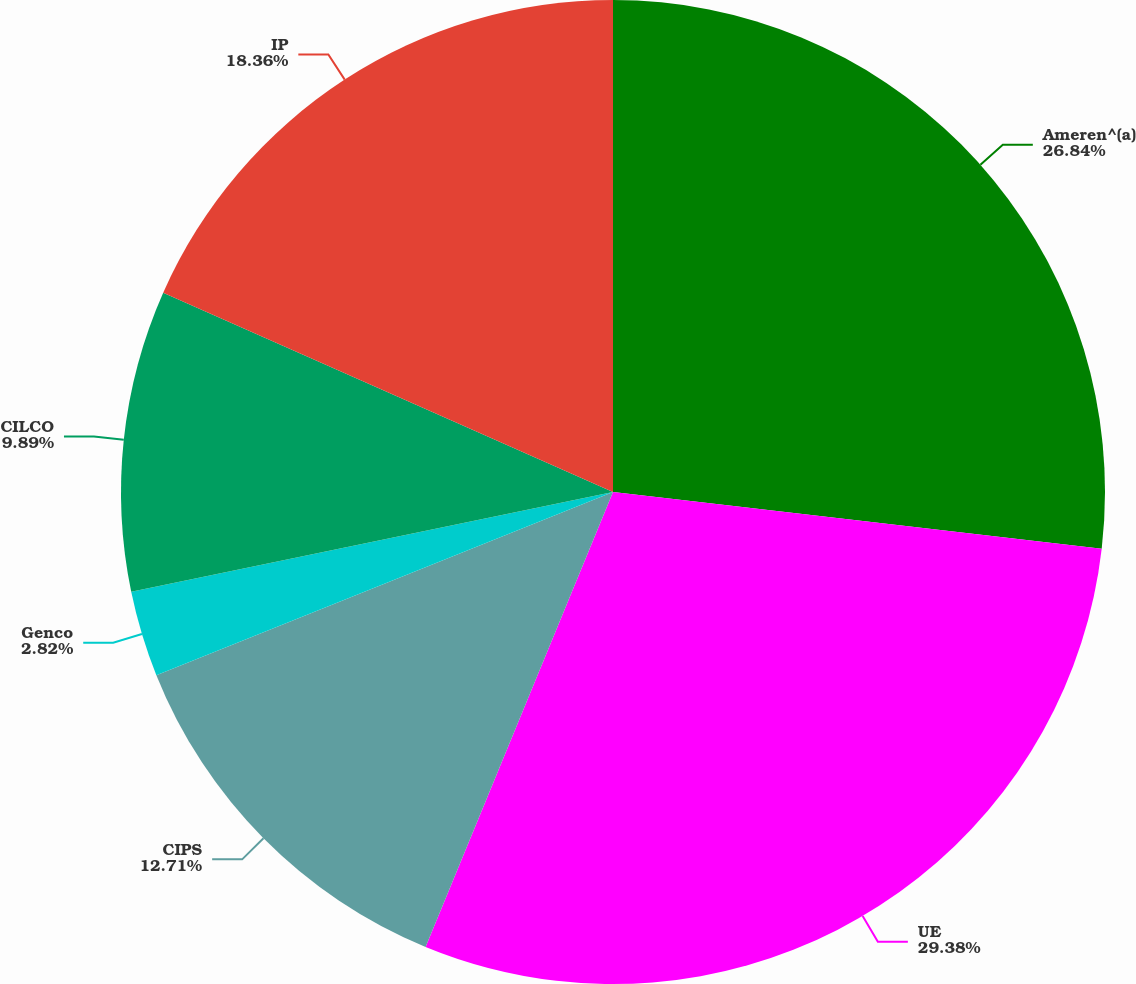<chart> <loc_0><loc_0><loc_500><loc_500><pie_chart><fcel>Ameren^(a)<fcel>UE<fcel>CIPS<fcel>Genco<fcel>CILCO<fcel>IP<nl><fcel>26.84%<fcel>29.38%<fcel>12.71%<fcel>2.82%<fcel>9.89%<fcel>18.36%<nl></chart> 